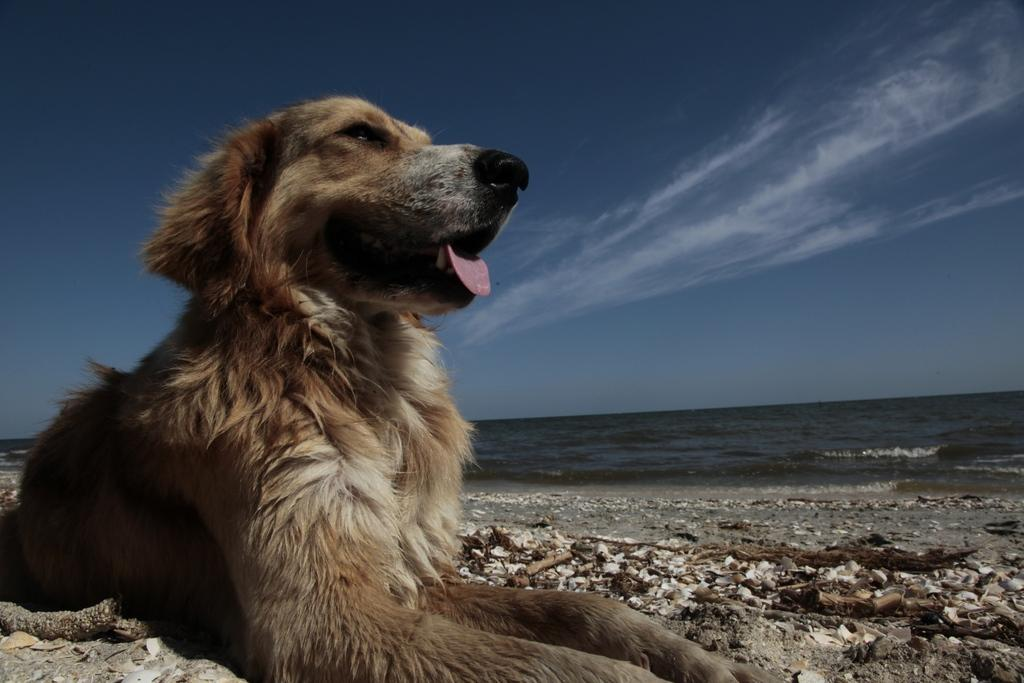What is the main subject in the foreground of the image? There is a dog in the foreground of the image. Where is the dog located in relation to the sea? The dog is in front of the sea. What can be seen at the top of the image? The sky is visible at the top of the image. What country is the dog starting to explore in the image? There is no indication of a specific country or the dog starting to explore in the image. 